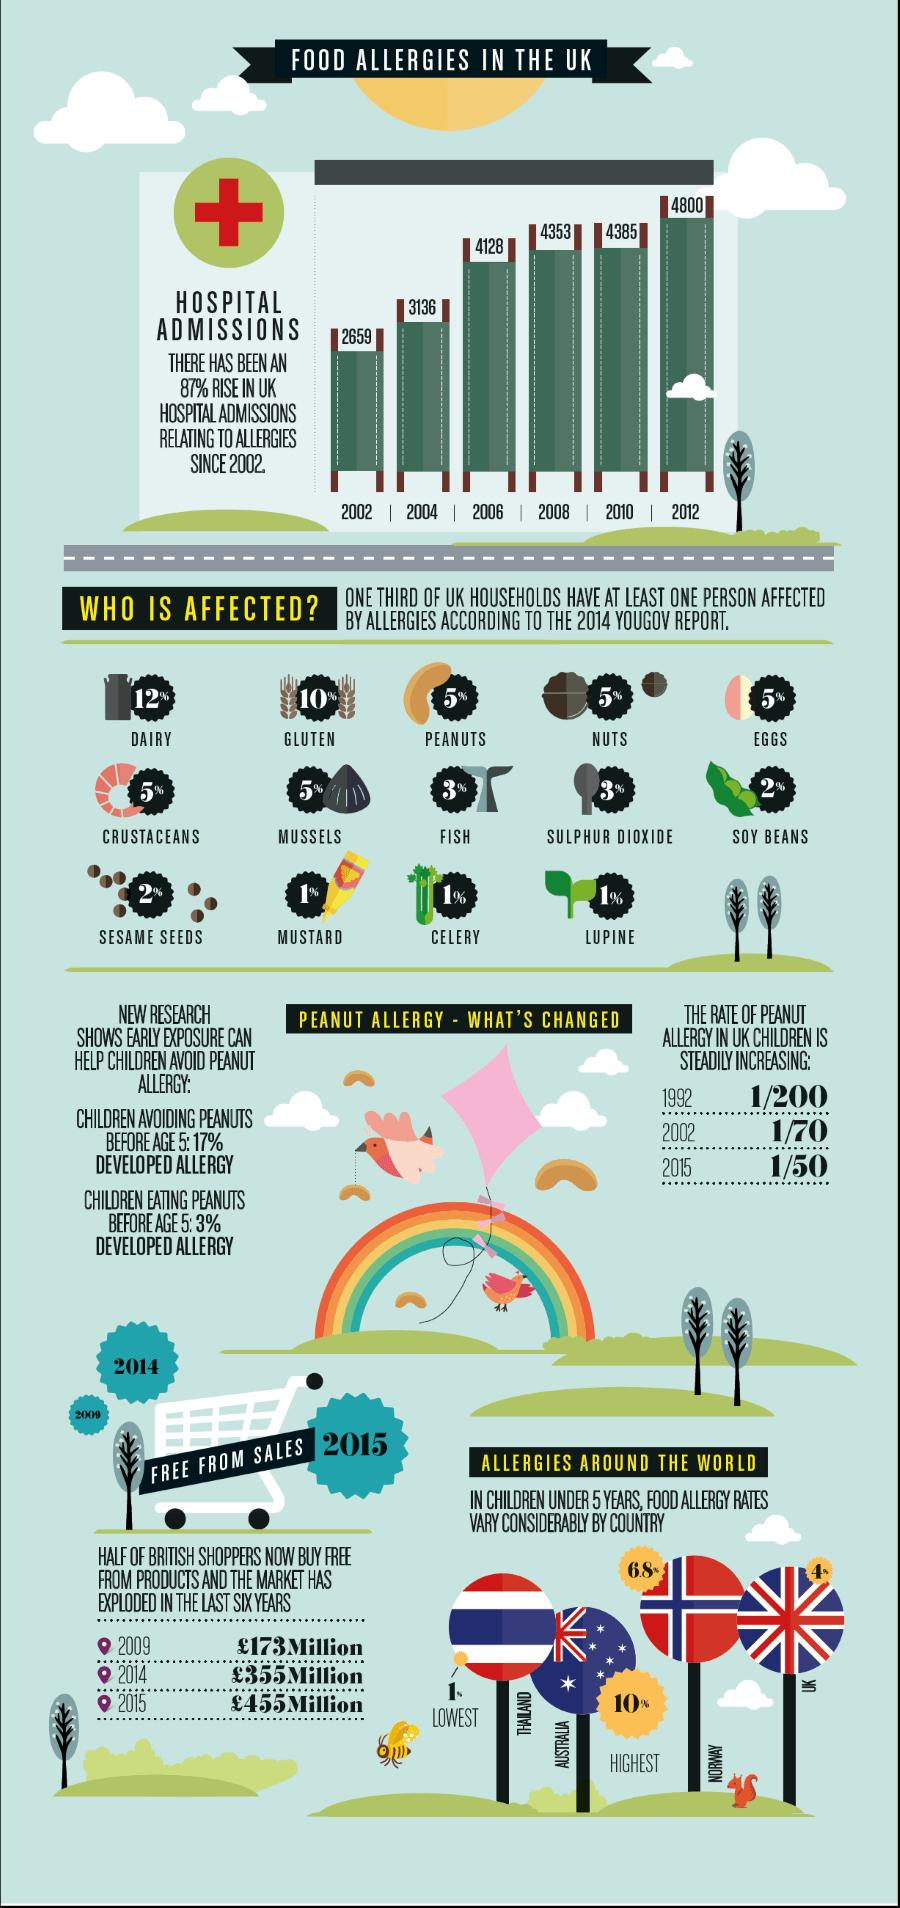Specify some key components in this picture. In the United Kingdom, the year 2012 reported the highest number of hospital admissions related to food allergies since the year 2002. According to a 2014 YouGov report, approximately 12% of the UK population has a diary allergy. According to a 2014 YouGov report, approximately 5% of the UK population has a peanut allergy. In the year 2002, the prevalence of peanut allergy among children in the UK was estimated to be approximately 1 in every 70 children. According to a 2014 YouGov report, approximately 10% of people in the UK have a gluten allergy. 